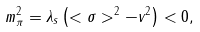Convert formula to latex. <formula><loc_0><loc_0><loc_500><loc_500>m _ { \pi } ^ { 2 } = \lambda _ { s } \left ( < \sigma > ^ { 2 } - v ^ { 2 } \right ) < 0 ,</formula> 